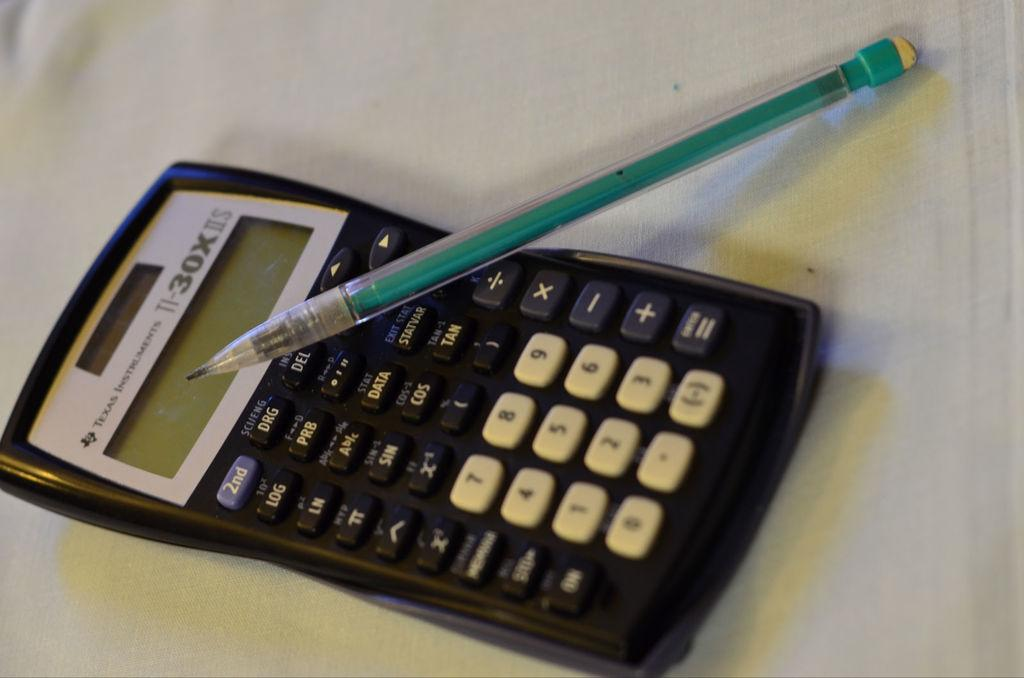<image>
Offer a succinct explanation of the picture presented. A TI-30x calculator with a pencil on top of it 